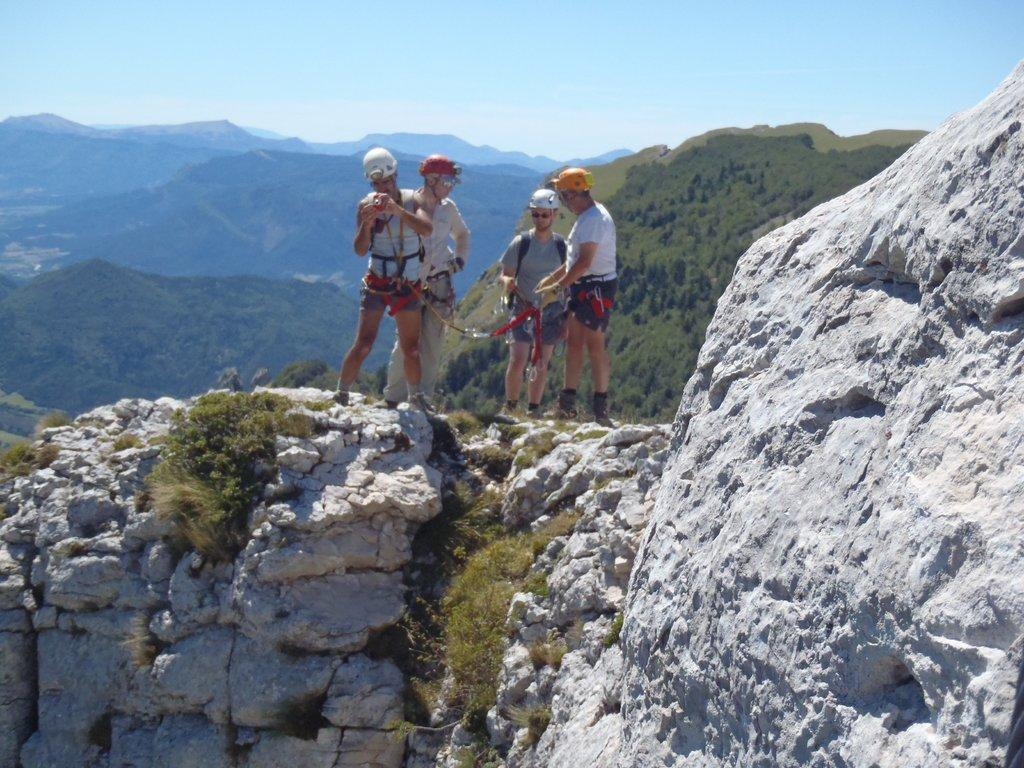How many people are in the image? There are four people in the image. What are the people wearing on their heads? The people are wearing helmets. What can be seen in the background of the image? There are trees and mountains in the background of the image. What color is the sky in the image? The sky is blue in the image. What type of harmony is being played by the people in the image? There is no indication of music or harmony in the image; the people are wearing helmets, which suggests they might be engaging in an outdoor activity. --- 